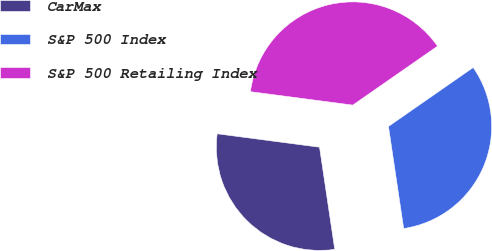Convert chart. <chart><loc_0><loc_0><loc_500><loc_500><pie_chart><fcel>CarMax<fcel>S&P 500 Index<fcel>S&P 500 Retailing Index<nl><fcel>29.43%<fcel>32.32%<fcel>38.25%<nl></chart> 